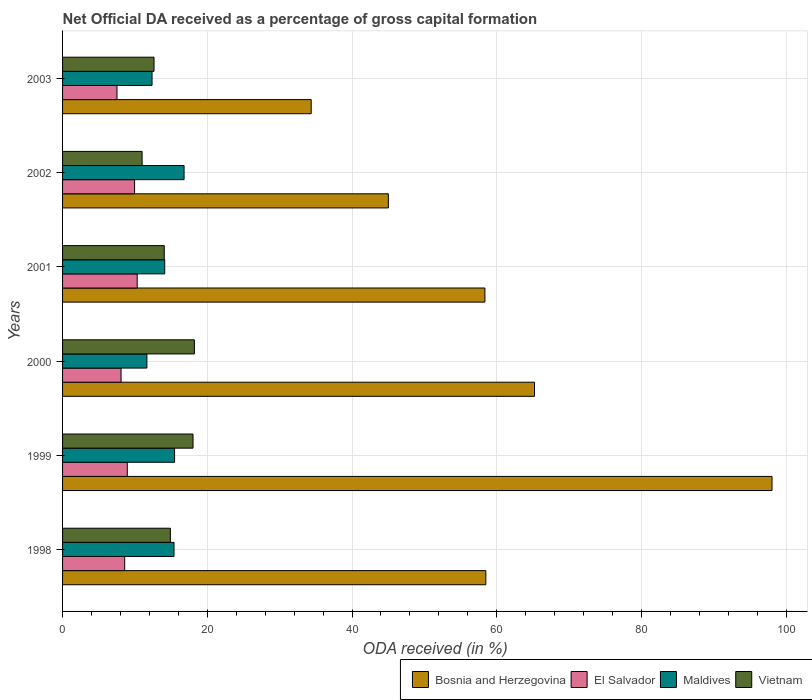How many different coloured bars are there?
Provide a succinct answer. 4. How many groups of bars are there?
Ensure brevity in your answer.  6. What is the net ODA received in Vietnam in 2002?
Provide a short and direct response. 10.99. Across all years, what is the maximum net ODA received in Maldives?
Your answer should be compact. 16.79. Across all years, what is the minimum net ODA received in El Salvador?
Make the answer very short. 7.52. In which year was the net ODA received in El Salvador maximum?
Offer a terse response. 2001. What is the total net ODA received in Bosnia and Herzegovina in the graph?
Your answer should be compact. 359.48. What is the difference between the net ODA received in Maldives in 1999 and that in 2001?
Offer a very short reply. 1.36. What is the difference between the net ODA received in Vietnam in 1999 and the net ODA received in El Salvador in 2003?
Offer a very short reply. 10.51. What is the average net ODA received in El Salvador per year?
Offer a terse response. 8.9. In the year 1999, what is the difference between the net ODA received in Bosnia and Herzegovina and net ODA received in El Salvador?
Provide a short and direct response. 89.09. What is the ratio of the net ODA received in Vietnam in 1999 to that in 2003?
Your answer should be compact. 1.43. Is the difference between the net ODA received in Bosnia and Herzegovina in 1999 and 2002 greater than the difference between the net ODA received in El Salvador in 1999 and 2002?
Provide a short and direct response. Yes. What is the difference between the highest and the second highest net ODA received in Bosnia and Herzegovina?
Offer a terse response. 32.82. What is the difference between the highest and the lowest net ODA received in El Salvador?
Keep it short and to the point. 2.79. In how many years, is the net ODA received in El Salvador greater than the average net ODA received in El Salvador taken over all years?
Your response must be concise. 3. Is the sum of the net ODA received in Vietnam in 2000 and 2003 greater than the maximum net ODA received in El Salvador across all years?
Make the answer very short. Yes. Is it the case that in every year, the sum of the net ODA received in Vietnam and net ODA received in Bosnia and Herzegovina is greater than the sum of net ODA received in El Salvador and net ODA received in Maldives?
Offer a terse response. Yes. What does the 1st bar from the top in 1999 represents?
Keep it short and to the point. Vietnam. What does the 3rd bar from the bottom in 1998 represents?
Make the answer very short. Maldives. Is it the case that in every year, the sum of the net ODA received in Maldives and net ODA received in Vietnam is greater than the net ODA received in El Salvador?
Your answer should be compact. Yes. How many bars are there?
Your answer should be compact. 24. Are all the bars in the graph horizontal?
Your answer should be very brief. Yes. What is the difference between two consecutive major ticks on the X-axis?
Your answer should be compact. 20. Does the graph contain any zero values?
Provide a succinct answer. No. Does the graph contain grids?
Your response must be concise. Yes. What is the title of the graph?
Your answer should be very brief. Net Official DA received as a percentage of gross capital formation. What is the label or title of the X-axis?
Offer a terse response. ODA received (in %). What is the label or title of the Y-axis?
Your answer should be compact. Years. What is the ODA received (in %) in Bosnia and Herzegovina in 1998?
Your answer should be very brief. 58.49. What is the ODA received (in %) in El Salvador in 1998?
Ensure brevity in your answer.  8.58. What is the ODA received (in %) of Maldives in 1998?
Keep it short and to the point. 15.4. What is the ODA received (in %) in Vietnam in 1998?
Provide a short and direct response. 14.89. What is the ODA received (in %) in Bosnia and Herzegovina in 1999?
Offer a terse response. 98.04. What is the ODA received (in %) of El Salvador in 1999?
Keep it short and to the point. 8.94. What is the ODA received (in %) of Maldives in 1999?
Your response must be concise. 15.48. What is the ODA received (in %) in Vietnam in 1999?
Give a very brief answer. 18.03. What is the ODA received (in %) in Bosnia and Herzegovina in 2000?
Ensure brevity in your answer.  65.21. What is the ODA received (in %) in El Salvador in 2000?
Give a very brief answer. 8.08. What is the ODA received (in %) in Maldives in 2000?
Provide a succinct answer. 11.65. What is the ODA received (in %) in Vietnam in 2000?
Offer a very short reply. 18.22. What is the ODA received (in %) in Bosnia and Herzegovina in 2001?
Your response must be concise. 58.36. What is the ODA received (in %) in El Salvador in 2001?
Provide a short and direct response. 10.31. What is the ODA received (in %) in Maldives in 2001?
Provide a short and direct response. 14.12. What is the ODA received (in %) in Vietnam in 2001?
Your response must be concise. 14.05. What is the ODA received (in %) in Bosnia and Herzegovina in 2002?
Your answer should be compact. 45.02. What is the ODA received (in %) of El Salvador in 2002?
Offer a terse response. 9.95. What is the ODA received (in %) in Maldives in 2002?
Your answer should be very brief. 16.79. What is the ODA received (in %) in Vietnam in 2002?
Give a very brief answer. 10.99. What is the ODA received (in %) of Bosnia and Herzegovina in 2003?
Keep it short and to the point. 34.36. What is the ODA received (in %) of El Salvador in 2003?
Your response must be concise. 7.52. What is the ODA received (in %) in Maldives in 2003?
Offer a terse response. 12.36. What is the ODA received (in %) of Vietnam in 2003?
Offer a terse response. 12.64. Across all years, what is the maximum ODA received (in %) in Bosnia and Herzegovina?
Offer a very short reply. 98.04. Across all years, what is the maximum ODA received (in %) in El Salvador?
Keep it short and to the point. 10.31. Across all years, what is the maximum ODA received (in %) of Maldives?
Provide a short and direct response. 16.79. Across all years, what is the maximum ODA received (in %) in Vietnam?
Ensure brevity in your answer.  18.22. Across all years, what is the minimum ODA received (in %) of Bosnia and Herzegovina?
Ensure brevity in your answer.  34.36. Across all years, what is the minimum ODA received (in %) in El Salvador?
Keep it short and to the point. 7.52. Across all years, what is the minimum ODA received (in %) in Maldives?
Make the answer very short. 11.65. Across all years, what is the minimum ODA received (in %) in Vietnam?
Offer a terse response. 10.99. What is the total ODA received (in %) in Bosnia and Herzegovina in the graph?
Give a very brief answer. 359.48. What is the total ODA received (in %) in El Salvador in the graph?
Offer a very short reply. 53.39. What is the total ODA received (in %) of Maldives in the graph?
Make the answer very short. 85.8. What is the total ODA received (in %) of Vietnam in the graph?
Ensure brevity in your answer.  88.82. What is the difference between the ODA received (in %) of Bosnia and Herzegovina in 1998 and that in 1999?
Give a very brief answer. -39.55. What is the difference between the ODA received (in %) in El Salvador in 1998 and that in 1999?
Your response must be concise. -0.36. What is the difference between the ODA received (in %) in Maldives in 1998 and that in 1999?
Ensure brevity in your answer.  -0.08. What is the difference between the ODA received (in %) of Vietnam in 1998 and that in 1999?
Your answer should be compact. -3.13. What is the difference between the ODA received (in %) in Bosnia and Herzegovina in 1998 and that in 2000?
Offer a terse response. -6.73. What is the difference between the ODA received (in %) in El Salvador in 1998 and that in 2000?
Provide a succinct answer. 0.5. What is the difference between the ODA received (in %) of Maldives in 1998 and that in 2000?
Your answer should be compact. 3.75. What is the difference between the ODA received (in %) in Vietnam in 1998 and that in 2000?
Your answer should be very brief. -3.32. What is the difference between the ODA received (in %) of Bosnia and Herzegovina in 1998 and that in 2001?
Provide a short and direct response. 0.13. What is the difference between the ODA received (in %) of El Salvador in 1998 and that in 2001?
Your answer should be compact. -1.73. What is the difference between the ODA received (in %) of Maldives in 1998 and that in 2001?
Your answer should be compact. 1.28. What is the difference between the ODA received (in %) of Vietnam in 1998 and that in 2001?
Provide a short and direct response. 0.84. What is the difference between the ODA received (in %) of Bosnia and Herzegovina in 1998 and that in 2002?
Make the answer very short. 13.47. What is the difference between the ODA received (in %) of El Salvador in 1998 and that in 2002?
Make the answer very short. -1.37. What is the difference between the ODA received (in %) of Maldives in 1998 and that in 2002?
Keep it short and to the point. -1.39. What is the difference between the ODA received (in %) in Vietnam in 1998 and that in 2002?
Your response must be concise. 3.9. What is the difference between the ODA received (in %) in Bosnia and Herzegovina in 1998 and that in 2003?
Your answer should be compact. 24.13. What is the difference between the ODA received (in %) in El Salvador in 1998 and that in 2003?
Offer a very short reply. 1.06. What is the difference between the ODA received (in %) in Maldives in 1998 and that in 2003?
Provide a short and direct response. 3.04. What is the difference between the ODA received (in %) in Vietnam in 1998 and that in 2003?
Make the answer very short. 2.26. What is the difference between the ODA received (in %) in Bosnia and Herzegovina in 1999 and that in 2000?
Offer a very short reply. 32.82. What is the difference between the ODA received (in %) of El Salvador in 1999 and that in 2000?
Keep it short and to the point. 0.86. What is the difference between the ODA received (in %) of Maldives in 1999 and that in 2000?
Provide a succinct answer. 3.83. What is the difference between the ODA received (in %) of Vietnam in 1999 and that in 2000?
Your response must be concise. -0.19. What is the difference between the ODA received (in %) of Bosnia and Herzegovina in 1999 and that in 2001?
Your answer should be compact. 39.68. What is the difference between the ODA received (in %) of El Salvador in 1999 and that in 2001?
Your answer should be compact. -1.37. What is the difference between the ODA received (in %) of Maldives in 1999 and that in 2001?
Provide a short and direct response. 1.36. What is the difference between the ODA received (in %) in Vietnam in 1999 and that in 2001?
Offer a very short reply. 3.97. What is the difference between the ODA received (in %) in Bosnia and Herzegovina in 1999 and that in 2002?
Make the answer very short. 53.01. What is the difference between the ODA received (in %) in El Salvador in 1999 and that in 2002?
Give a very brief answer. -1.01. What is the difference between the ODA received (in %) of Maldives in 1999 and that in 2002?
Provide a short and direct response. -1.31. What is the difference between the ODA received (in %) of Vietnam in 1999 and that in 2002?
Provide a short and direct response. 7.04. What is the difference between the ODA received (in %) in Bosnia and Herzegovina in 1999 and that in 2003?
Offer a terse response. 63.68. What is the difference between the ODA received (in %) of El Salvador in 1999 and that in 2003?
Your answer should be very brief. 1.42. What is the difference between the ODA received (in %) of Maldives in 1999 and that in 2003?
Keep it short and to the point. 3.11. What is the difference between the ODA received (in %) of Vietnam in 1999 and that in 2003?
Your answer should be compact. 5.39. What is the difference between the ODA received (in %) of Bosnia and Herzegovina in 2000 and that in 2001?
Your response must be concise. 6.85. What is the difference between the ODA received (in %) of El Salvador in 2000 and that in 2001?
Keep it short and to the point. -2.23. What is the difference between the ODA received (in %) in Maldives in 2000 and that in 2001?
Keep it short and to the point. -2.46. What is the difference between the ODA received (in %) of Vietnam in 2000 and that in 2001?
Offer a very short reply. 4.16. What is the difference between the ODA received (in %) in Bosnia and Herzegovina in 2000 and that in 2002?
Your answer should be compact. 20.19. What is the difference between the ODA received (in %) of El Salvador in 2000 and that in 2002?
Make the answer very short. -1.87. What is the difference between the ODA received (in %) of Maldives in 2000 and that in 2002?
Provide a short and direct response. -5.14. What is the difference between the ODA received (in %) of Vietnam in 2000 and that in 2002?
Your answer should be compact. 7.23. What is the difference between the ODA received (in %) in Bosnia and Herzegovina in 2000 and that in 2003?
Your answer should be very brief. 30.86. What is the difference between the ODA received (in %) of El Salvador in 2000 and that in 2003?
Your answer should be compact. 0.56. What is the difference between the ODA received (in %) of Maldives in 2000 and that in 2003?
Offer a very short reply. -0.71. What is the difference between the ODA received (in %) of Vietnam in 2000 and that in 2003?
Make the answer very short. 5.58. What is the difference between the ODA received (in %) of Bosnia and Herzegovina in 2001 and that in 2002?
Offer a terse response. 13.34. What is the difference between the ODA received (in %) of El Salvador in 2001 and that in 2002?
Provide a succinct answer. 0.36. What is the difference between the ODA received (in %) of Maldives in 2001 and that in 2002?
Your response must be concise. -2.67. What is the difference between the ODA received (in %) in Vietnam in 2001 and that in 2002?
Your answer should be very brief. 3.06. What is the difference between the ODA received (in %) of Bosnia and Herzegovina in 2001 and that in 2003?
Keep it short and to the point. 24. What is the difference between the ODA received (in %) of El Salvador in 2001 and that in 2003?
Your response must be concise. 2.79. What is the difference between the ODA received (in %) of Maldives in 2001 and that in 2003?
Provide a short and direct response. 1.75. What is the difference between the ODA received (in %) in Vietnam in 2001 and that in 2003?
Ensure brevity in your answer.  1.42. What is the difference between the ODA received (in %) in Bosnia and Herzegovina in 2002 and that in 2003?
Provide a short and direct response. 10.66. What is the difference between the ODA received (in %) in El Salvador in 2002 and that in 2003?
Ensure brevity in your answer.  2.43. What is the difference between the ODA received (in %) of Maldives in 2002 and that in 2003?
Make the answer very short. 4.43. What is the difference between the ODA received (in %) in Vietnam in 2002 and that in 2003?
Make the answer very short. -1.65. What is the difference between the ODA received (in %) of Bosnia and Herzegovina in 1998 and the ODA received (in %) of El Salvador in 1999?
Keep it short and to the point. 49.55. What is the difference between the ODA received (in %) of Bosnia and Herzegovina in 1998 and the ODA received (in %) of Maldives in 1999?
Offer a terse response. 43.01. What is the difference between the ODA received (in %) in Bosnia and Herzegovina in 1998 and the ODA received (in %) in Vietnam in 1999?
Your answer should be compact. 40.46. What is the difference between the ODA received (in %) of El Salvador in 1998 and the ODA received (in %) of Maldives in 1999?
Keep it short and to the point. -6.89. What is the difference between the ODA received (in %) in El Salvador in 1998 and the ODA received (in %) in Vietnam in 1999?
Provide a short and direct response. -9.44. What is the difference between the ODA received (in %) of Maldives in 1998 and the ODA received (in %) of Vietnam in 1999?
Provide a succinct answer. -2.62. What is the difference between the ODA received (in %) of Bosnia and Herzegovina in 1998 and the ODA received (in %) of El Salvador in 2000?
Provide a short and direct response. 50.41. What is the difference between the ODA received (in %) of Bosnia and Herzegovina in 1998 and the ODA received (in %) of Maldives in 2000?
Ensure brevity in your answer.  46.84. What is the difference between the ODA received (in %) of Bosnia and Herzegovina in 1998 and the ODA received (in %) of Vietnam in 2000?
Ensure brevity in your answer.  40.27. What is the difference between the ODA received (in %) of El Salvador in 1998 and the ODA received (in %) of Maldives in 2000?
Provide a succinct answer. -3.07. What is the difference between the ODA received (in %) of El Salvador in 1998 and the ODA received (in %) of Vietnam in 2000?
Your response must be concise. -9.63. What is the difference between the ODA received (in %) in Maldives in 1998 and the ODA received (in %) in Vietnam in 2000?
Give a very brief answer. -2.81. What is the difference between the ODA received (in %) in Bosnia and Herzegovina in 1998 and the ODA received (in %) in El Salvador in 2001?
Make the answer very short. 48.17. What is the difference between the ODA received (in %) in Bosnia and Herzegovina in 1998 and the ODA received (in %) in Maldives in 2001?
Your response must be concise. 44.37. What is the difference between the ODA received (in %) of Bosnia and Herzegovina in 1998 and the ODA received (in %) of Vietnam in 2001?
Offer a very short reply. 44.43. What is the difference between the ODA received (in %) of El Salvador in 1998 and the ODA received (in %) of Maldives in 2001?
Provide a short and direct response. -5.53. What is the difference between the ODA received (in %) in El Salvador in 1998 and the ODA received (in %) in Vietnam in 2001?
Offer a very short reply. -5.47. What is the difference between the ODA received (in %) in Maldives in 1998 and the ODA received (in %) in Vietnam in 2001?
Make the answer very short. 1.35. What is the difference between the ODA received (in %) in Bosnia and Herzegovina in 1998 and the ODA received (in %) in El Salvador in 2002?
Provide a succinct answer. 48.54. What is the difference between the ODA received (in %) of Bosnia and Herzegovina in 1998 and the ODA received (in %) of Maldives in 2002?
Provide a succinct answer. 41.7. What is the difference between the ODA received (in %) of Bosnia and Herzegovina in 1998 and the ODA received (in %) of Vietnam in 2002?
Your answer should be compact. 47.5. What is the difference between the ODA received (in %) in El Salvador in 1998 and the ODA received (in %) in Maldives in 2002?
Provide a succinct answer. -8.21. What is the difference between the ODA received (in %) of El Salvador in 1998 and the ODA received (in %) of Vietnam in 2002?
Your answer should be very brief. -2.41. What is the difference between the ODA received (in %) in Maldives in 1998 and the ODA received (in %) in Vietnam in 2002?
Offer a very short reply. 4.41. What is the difference between the ODA received (in %) of Bosnia and Herzegovina in 1998 and the ODA received (in %) of El Salvador in 2003?
Ensure brevity in your answer.  50.97. What is the difference between the ODA received (in %) in Bosnia and Herzegovina in 1998 and the ODA received (in %) in Maldives in 2003?
Ensure brevity in your answer.  46.12. What is the difference between the ODA received (in %) of Bosnia and Herzegovina in 1998 and the ODA received (in %) of Vietnam in 2003?
Offer a very short reply. 45.85. What is the difference between the ODA received (in %) of El Salvador in 1998 and the ODA received (in %) of Maldives in 2003?
Keep it short and to the point. -3.78. What is the difference between the ODA received (in %) of El Salvador in 1998 and the ODA received (in %) of Vietnam in 2003?
Ensure brevity in your answer.  -4.06. What is the difference between the ODA received (in %) in Maldives in 1998 and the ODA received (in %) in Vietnam in 2003?
Provide a short and direct response. 2.76. What is the difference between the ODA received (in %) of Bosnia and Herzegovina in 1999 and the ODA received (in %) of El Salvador in 2000?
Make the answer very short. 89.95. What is the difference between the ODA received (in %) in Bosnia and Herzegovina in 1999 and the ODA received (in %) in Maldives in 2000?
Offer a very short reply. 86.38. What is the difference between the ODA received (in %) of Bosnia and Herzegovina in 1999 and the ODA received (in %) of Vietnam in 2000?
Offer a terse response. 79.82. What is the difference between the ODA received (in %) in El Salvador in 1999 and the ODA received (in %) in Maldives in 2000?
Keep it short and to the point. -2.71. What is the difference between the ODA received (in %) in El Salvador in 1999 and the ODA received (in %) in Vietnam in 2000?
Ensure brevity in your answer.  -9.27. What is the difference between the ODA received (in %) in Maldives in 1999 and the ODA received (in %) in Vietnam in 2000?
Offer a terse response. -2.74. What is the difference between the ODA received (in %) of Bosnia and Herzegovina in 1999 and the ODA received (in %) of El Salvador in 2001?
Your answer should be compact. 87.72. What is the difference between the ODA received (in %) of Bosnia and Herzegovina in 1999 and the ODA received (in %) of Maldives in 2001?
Your response must be concise. 83.92. What is the difference between the ODA received (in %) in Bosnia and Herzegovina in 1999 and the ODA received (in %) in Vietnam in 2001?
Your response must be concise. 83.98. What is the difference between the ODA received (in %) in El Salvador in 1999 and the ODA received (in %) in Maldives in 2001?
Your answer should be compact. -5.17. What is the difference between the ODA received (in %) of El Salvador in 1999 and the ODA received (in %) of Vietnam in 2001?
Your answer should be very brief. -5.11. What is the difference between the ODA received (in %) of Maldives in 1999 and the ODA received (in %) of Vietnam in 2001?
Give a very brief answer. 1.42. What is the difference between the ODA received (in %) of Bosnia and Herzegovina in 1999 and the ODA received (in %) of El Salvador in 2002?
Provide a succinct answer. 88.09. What is the difference between the ODA received (in %) in Bosnia and Herzegovina in 1999 and the ODA received (in %) in Maldives in 2002?
Give a very brief answer. 81.25. What is the difference between the ODA received (in %) of Bosnia and Herzegovina in 1999 and the ODA received (in %) of Vietnam in 2002?
Offer a very short reply. 87.05. What is the difference between the ODA received (in %) of El Salvador in 1999 and the ODA received (in %) of Maldives in 2002?
Provide a short and direct response. -7.85. What is the difference between the ODA received (in %) of El Salvador in 1999 and the ODA received (in %) of Vietnam in 2002?
Offer a very short reply. -2.05. What is the difference between the ODA received (in %) in Maldives in 1999 and the ODA received (in %) in Vietnam in 2002?
Provide a short and direct response. 4.49. What is the difference between the ODA received (in %) of Bosnia and Herzegovina in 1999 and the ODA received (in %) of El Salvador in 2003?
Give a very brief answer. 90.52. What is the difference between the ODA received (in %) in Bosnia and Herzegovina in 1999 and the ODA received (in %) in Maldives in 2003?
Make the answer very short. 85.67. What is the difference between the ODA received (in %) in Bosnia and Herzegovina in 1999 and the ODA received (in %) in Vietnam in 2003?
Give a very brief answer. 85.4. What is the difference between the ODA received (in %) of El Salvador in 1999 and the ODA received (in %) of Maldives in 2003?
Provide a short and direct response. -3.42. What is the difference between the ODA received (in %) of El Salvador in 1999 and the ODA received (in %) of Vietnam in 2003?
Give a very brief answer. -3.7. What is the difference between the ODA received (in %) in Maldives in 1999 and the ODA received (in %) in Vietnam in 2003?
Offer a very short reply. 2.84. What is the difference between the ODA received (in %) in Bosnia and Herzegovina in 2000 and the ODA received (in %) in El Salvador in 2001?
Provide a short and direct response. 54.9. What is the difference between the ODA received (in %) of Bosnia and Herzegovina in 2000 and the ODA received (in %) of Maldives in 2001?
Your answer should be compact. 51.1. What is the difference between the ODA received (in %) in Bosnia and Herzegovina in 2000 and the ODA received (in %) in Vietnam in 2001?
Give a very brief answer. 51.16. What is the difference between the ODA received (in %) of El Salvador in 2000 and the ODA received (in %) of Maldives in 2001?
Offer a very short reply. -6.04. What is the difference between the ODA received (in %) in El Salvador in 2000 and the ODA received (in %) in Vietnam in 2001?
Ensure brevity in your answer.  -5.97. What is the difference between the ODA received (in %) in Maldives in 2000 and the ODA received (in %) in Vietnam in 2001?
Give a very brief answer. -2.4. What is the difference between the ODA received (in %) of Bosnia and Herzegovina in 2000 and the ODA received (in %) of El Salvador in 2002?
Your answer should be very brief. 55.26. What is the difference between the ODA received (in %) in Bosnia and Herzegovina in 2000 and the ODA received (in %) in Maldives in 2002?
Your answer should be compact. 48.42. What is the difference between the ODA received (in %) in Bosnia and Herzegovina in 2000 and the ODA received (in %) in Vietnam in 2002?
Provide a short and direct response. 54.22. What is the difference between the ODA received (in %) of El Salvador in 2000 and the ODA received (in %) of Maldives in 2002?
Provide a succinct answer. -8.71. What is the difference between the ODA received (in %) in El Salvador in 2000 and the ODA received (in %) in Vietnam in 2002?
Provide a short and direct response. -2.91. What is the difference between the ODA received (in %) of Maldives in 2000 and the ODA received (in %) of Vietnam in 2002?
Give a very brief answer. 0.66. What is the difference between the ODA received (in %) of Bosnia and Herzegovina in 2000 and the ODA received (in %) of El Salvador in 2003?
Your response must be concise. 57.69. What is the difference between the ODA received (in %) in Bosnia and Herzegovina in 2000 and the ODA received (in %) in Maldives in 2003?
Ensure brevity in your answer.  52.85. What is the difference between the ODA received (in %) in Bosnia and Herzegovina in 2000 and the ODA received (in %) in Vietnam in 2003?
Offer a terse response. 52.58. What is the difference between the ODA received (in %) in El Salvador in 2000 and the ODA received (in %) in Maldives in 2003?
Provide a short and direct response. -4.28. What is the difference between the ODA received (in %) of El Salvador in 2000 and the ODA received (in %) of Vietnam in 2003?
Give a very brief answer. -4.56. What is the difference between the ODA received (in %) of Maldives in 2000 and the ODA received (in %) of Vietnam in 2003?
Your response must be concise. -0.99. What is the difference between the ODA received (in %) of Bosnia and Herzegovina in 2001 and the ODA received (in %) of El Salvador in 2002?
Offer a terse response. 48.41. What is the difference between the ODA received (in %) of Bosnia and Herzegovina in 2001 and the ODA received (in %) of Maldives in 2002?
Give a very brief answer. 41.57. What is the difference between the ODA received (in %) in Bosnia and Herzegovina in 2001 and the ODA received (in %) in Vietnam in 2002?
Your answer should be compact. 47.37. What is the difference between the ODA received (in %) in El Salvador in 2001 and the ODA received (in %) in Maldives in 2002?
Keep it short and to the point. -6.48. What is the difference between the ODA received (in %) in El Salvador in 2001 and the ODA received (in %) in Vietnam in 2002?
Your answer should be compact. -0.68. What is the difference between the ODA received (in %) in Maldives in 2001 and the ODA received (in %) in Vietnam in 2002?
Provide a succinct answer. 3.13. What is the difference between the ODA received (in %) of Bosnia and Herzegovina in 2001 and the ODA received (in %) of El Salvador in 2003?
Provide a succinct answer. 50.84. What is the difference between the ODA received (in %) of Bosnia and Herzegovina in 2001 and the ODA received (in %) of Maldives in 2003?
Offer a terse response. 46. What is the difference between the ODA received (in %) of Bosnia and Herzegovina in 2001 and the ODA received (in %) of Vietnam in 2003?
Offer a terse response. 45.72. What is the difference between the ODA received (in %) in El Salvador in 2001 and the ODA received (in %) in Maldives in 2003?
Provide a succinct answer. -2.05. What is the difference between the ODA received (in %) of El Salvador in 2001 and the ODA received (in %) of Vietnam in 2003?
Keep it short and to the point. -2.32. What is the difference between the ODA received (in %) of Maldives in 2001 and the ODA received (in %) of Vietnam in 2003?
Your answer should be compact. 1.48. What is the difference between the ODA received (in %) in Bosnia and Herzegovina in 2002 and the ODA received (in %) in El Salvador in 2003?
Keep it short and to the point. 37.5. What is the difference between the ODA received (in %) in Bosnia and Herzegovina in 2002 and the ODA received (in %) in Maldives in 2003?
Your response must be concise. 32.66. What is the difference between the ODA received (in %) of Bosnia and Herzegovina in 2002 and the ODA received (in %) of Vietnam in 2003?
Make the answer very short. 32.38. What is the difference between the ODA received (in %) in El Salvador in 2002 and the ODA received (in %) in Maldives in 2003?
Provide a succinct answer. -2.41. What is the difference between the ODA received (in %) of El Salvador in 2002 and the ODA received (in %) of Vietnam in 2003?
Ensure brevity in your answer.  -2.69. What is the difference between the ODA received (in %) in Maldives in 2002 and the ODA received (in %) in Vietnam in 2003?
Ensure brevity in your answer.  4.15. What is the average ODA received (in %) of Bosnia and Herzegovina per year?
Give a very brief answer. 59.91. What is the average ODA received (in %) of El Salvador per year?
Keep it short and to the point. 8.9. What is the average ODA received (in %) of Maldives per year?
Make the answer very short. 14.3. What is the average ODA received (in %) of Vietnam per year?
Give a very brief answer. 14.8. In the year 1998, what is the difference between the ODA received (in %) in Bosnia and Herzegovina and ODA received (in %) in El Salvador?
Provide a short and direct response. 49.91. In the year 1998, what is the difference between the ODA received (in %) in Bosnia and Herzegovina and ODA received (in %) in Maldives?
Your answer should be compact. 43.09. In the year 1998, what is the difference between the ODA received (in %) in Bosnia and Herzegovina and ODA received (in %) in Vietnam?
Make the answer very short. 43.59. In the year 1998, what is the difference between the ODA received (in %) of El Salvador and ODA received (in %) of Maldives?
Your response must be concise. -6.82. In the year 1998, what is the difference between the ODA received (in %) of El Salvador and ODA received (in %) of Vietnam?
Your response must be concise. -6.31. In the year 1998, what is the difference between the ODA received (in %) in Maldives and ODA received (in %) in Vietnam?
Your response must be concise. 0.51. In the year 1999, what is the difference between the ODA received (in %) of Bosnia and Herzegovina and ODA received (in %) of El Salvador?
Provide a short and direct response. 89.09. In the year 1999, what is the difference between the ODA received (in %) in Bosnia and Herzegovina and ODA received (in %) in Maldives?
Provide a succinct answer. 82.56. In the year 1999, what is the difference between the ODA received (in %) in Bosnia and Herzegovina and ODA received (in %) in Vietnam?
Provide a succinct answer. 80.01. In the year 1999, what is the difference between the ODA received (in %) in El Salvador and ODA received (in %) in Maldives?
Give a very brief answer. -6.54. In the year 1999, what is the difference between the ODA received (in %) of El Salvador and ODA received (in %) of Vietnam?
Your response must be concise. -9.08. In the year 1999, what is the difference between the ODA received (in %) in Maldives and ODA received (in %) in Vietnam?
Offer a terse response. -2.55. In the year 2000, what is the difference between the ODA received (in %) in Bosnia and Herzegovina and ODA received (in %) in El Salvador?
Offer a very short reply. 57.13. In the year 2000, what is the difference between the ODA received (in %) of Bosnia and Herzegovina and ODA received (in %) of Maldives?
Provide a short and direct response. 53.56. In the year 2000, what is the difference between the ODA received (in %) of Bosnia and Herzegovina and ODA received (in %) of Vietnam?
Provide a short and direct response. 47. In the year 2000, what is the difference between the ODA received (in %) in El Salvador and ODA received (in %) in Maldives?
Keep it short and to the point. -3.57. In the year 2000, what is the difference between the ODA received (in %) of El Salvador and ODA received (in %) of Vietnam?
Your answer should be compact. -10.13. In the year 2000, what is the difference between the ODA received (in %) in Maldives and ODA received (in %) in Vietnam?
Your answer should be compact. -6.56. In the year 2001, what is the difference between the ODA received (in %) in Bosnia and Herzegovina and ODA received (in %) in El Salvador?
Provide a succinct answer. 48.05. In the year 2001, what is the difference between the ODA received (in %) in Bosnia and Herzegovina and ODA received (in %) in Maldives?
Offer a terse response. 44.24. In the year 2001, what is the difference between the ODA received (in %) of Bosnia and Herzegovina and ODA received (in %) of Vietnam?
Provide a short and direct response. 44.31. In the year 2001, what is the difference between the ODA received (in %) in El Salvador and ODA received (in %) in Maldives?
Give a very brief answer. -3.8. In the year 2001, what is the difference between the ODA received (in %) in El Salvador and ODA received (in %) in Vietnam?
Your answer should be very brief. -3.74. In the year 2001, what is the difference between the ODA received (in %) of Maldives and ODA received (in %) of Vietnam?
Make the answer very short. 0.06. In the year 2002, what is the difference between the ODA received (in %) in Bosnia and Herzegovina and ODA received (in %) in El Salvador?
Provide a short and direct response. 35.07. In the year 2002, what is the difference between the ODA received (in %) of Bosnia and Herzegovina and ODA received (in %) of Maldives?
Your response must be concise. 28.23. In the year 2002, what is the difference between the ODA received (in %) of Bosnia and Herzegovina and ODA received (in %) of Vietnam?
Your answer should be very brief. 34.03. In the year 2002, what is the difference between the ODA received (in %) in El Salvador and ODA received (in %) in Maldives?
Keep it short and to the point. -6.84. In the year 2002, what is the difference between the ODA received (in %) of El Salvador and ODA received (in %) of Vietnam?
Make the answer very short. -1.04. In the year 2002, what is the difference between the ODA received (in %) of Maldives and ODA received (in %) of Vietnam?
Offer a very short reply. 5.8. In the year 2003, what is the difference between the ODA received (in %) in Bosnia and Herzegovina and ODA received (in %) in El Salvador?
Make the answer very short. 26.84. In the year 2003, what is the difference between the ODA received (in %) in Bosnia and Herzegovina and ODA received (in %) in Maldives?
Your answer should be compact. 21.99. In the year 2003, what is the difference between the ODA received (in %) in Bosnia and Herzegovina and ODA received (in %) in Vietnam?
Give a very brief answer. 21.72. In the year 2003, what is the difference between the ODA received (in %) of El Salvador and ODA received (in %) of Maldives?
Ensure brevity in your answer.  -4.84. In the year 2003, what is the difference between the ODA received (in %) of El Salvador and ODA received (in %) of Vietnam?
Provide a short and direct response. -5.12. In the year 2003, what is the difference between the ODA received (in %) in Maldives and ODA received (in %) in Vietnam?
Ensure brevity in your answer.  -0.27. What is the ratio of the ODA received (in %) of Bosnia and Herzegovina in 1998 to that in 1999?
Offer a terse response. 0.6. What is the ratio of the ODA received (in %) of El Salvador in 1998 to that in 1999?
Provide a succinct answer. 0.96. What is the ratio of the ODA received (in %) in Maldives in 1998 to that in 1999?
Your response must be concise. 1. What is the ratio of the ODA received (in %) in Vietnam in 1998 to that in 1999?
Ensure brevity in your answer.  0.83. What is the ratio of the ODA received (in %) in Bosnia and Herzegovina in 1998 to that in 2000?
Provide a succinct answer. 0.9. What is the ratio of the ODA received (in %) of El Salvador in 1998 to that in 2000?
Your response must be concise. 1.06. What is the ratio of the ODA received (in %) of Maldives in 1998 to that in 2000?
Offer a very short reply. 1.32. What is the ratio of the ODA received (in %) in Vietnam in 1998 to that in 2000?
Provide a succinct answer. 0.82. What is the ratio of the ODA received (in %) of El Salvador in 1998 to that in 2001?
Offer a very short reply. 0.83. What is the ratio of the ODA received (in %) of Maldives in 1998 to that in 2001?
Ensure brevity in your answer.  1.09. What is the ratio of the ODA received (in %) in Vietnam in 1998 to that in 2001?
Provide a short and direct response. 1.06. What is the ratio of the ODA received (in %) in Bosnia and Herzegovina in 1998 to that in 2002?
Provide a short and direct response. 1.3. What is the ratio of the ODA received (in %) of El Salvador in 1998 to that in 2002?
Provide a short and direct response. 0.86. What is the ratio of the ODA received (in %) of Maldives in 1998 to that in 2002?
Provide a short and direct response. 0.92. What is the ratio of the ODA received (in %) in Vietnam in 1998 to that in 2002?
Give a very brief answer. 1.36. What is the ratio of the ODA received (in %) of Bosnia and Herzegovina in 1998 to that in 2003?
Provide a short and direct response. 1.7. What is the ratio of the ODA received (in %) in El Salvador in 1998 to that in 2003?
Keep it short and to the point. 1.14. What is the ratio of the ODA received (in %) of Maldives in 1998 to that in 2003?
Ensure brevity in your answer.  1.25. What is the ratio of the ODA received (in %) in Vietnam in 1998 to that in 2003?
Offer a very short reply. 1.18. What is the ratio of the ODA received (in %) in Bosnia and Herzegovina in 1999 to that in 2000?
Give a very brief answer. 1.5. What is the ratio of the ODA received (in %) in El Salvador in 1999 to that in 2000?
Your answer should be very brief. 1.11. What is the ratio of the ODA received (in %) in Maldives in 1999 to that in 2000?
Your answer should be compact. 1.33. What is the ratio of the ODA received (in %) of Vietnam in 1999 to that in 2000?
Offer a terse response. 0.99. What is the ratio of the ODA received (in %) of Bosnia and Herzegovina in 1999 to that in 2001?
Offer a terse response. 1.68. What is the ratio of the ODA received (in %) in El Salvador in 1999 to that in 2001?
Provide a succinct answer. 0.87. What is the ratio of the ODA received (in %) in Maldives in 1999 to that in 2001?
Your response must be concise. 1.1. What is the ratio of the ODA received (in %) of Vietnam in 1999 to that in 2001?
Make the answer very short. 1.28. What is the ratio of the ODA received (in %) in Bosnia and Herzegovina in 1999 to that in 2002?
Your answer should be very brief. 2.18. What is the ratio of the ODA received (in %) in El Salvador in 1999 to that in 2002?
Offer a terse response. 0.9. What is the ratio of the ODA received (in %) of Maldives in 1999 to that in 2002?
Make the answer very short. 0.92. What is the ratio of the ODA received (in %) of Vietnam in 1999 to that in 2002?
Keep it short and to the point. 1.64. What is the ratio of the ODA received (in %) in Bosnia and Herzegovina in 1999 to that in 2003?
Keep it short and to the point. 2.85. What is the ratio of the ODA received (in %) in El Salvador in 1999 to that in 2003?
Provide a succinct answer. 1.19. What is the ratio of the ODA received (in %) in Maldives in 1999 to that in 2003?
Offer a terse response. 1.25. What is the ratio of the ODA received (in %) of Vietnam in 1999 to that in 2003?
Provide a short and direct response. 1.43. What is the ratio of the ODA received (in %) of Bosnia and Herzegovina in 2000 to that in 2001?
Your response must be concise. 1.12. What is the ratio of the ODA received (in %) in El Salvador in 2000 to that in 2001?
Provide a succinct answer. 0.78. What is the ratio of the ODA received (in %) in Maldives in 2000 to that in 2001?
Your answer should be very brief. 0.83. What is the ratio of the ODA received (in %) of Vietnam in 2000 to that in 2001?
Your answer should be compact. 1.3. What is the ratio of the ODA received (in %) in Bosnia and Herzegovina in 2000 to that in 2002?
Provide a succinct answer. 1.45. What is the ratio of the ODA received (in %) in El Salvador in 2000 to that in 2002?
Your response must be concise. 0.81. What is the ratio of the ODA received (in %) in Maldives in 2000 to that in 2002?
Offer a very short reply. 0.69. What is the ratio of the ODA received (in %) in Vietnam in 2000 to that in 2002?
Ensure brevity in your answer.  1.66. What is the ratio of the ODA received (in %) of Bosnia and Herzegovina in 2000 to that in 2003?
Make the answer very short. 1.9. What is the ratio of the ODA received (in %) of El Salvador in 2000 to that in 2003?
Provide a short and direct response. 1.07. What is the ratio of the ODA received (in %) in Maldives in 2000 to that in 2003?
Your answer should be very brief. 0.94. What is the ratio of the ODA received (in %) of Vietnam in 2000 to that in 2003?
Your answer should be compact. 1.44. What is the ratio of the ODA received (in %) in Bosnia and Herzegovina in 2001 to that in 2002?
Give a very brief answer. 1.3. What is the ratio of the ODA received (in %) in El Salvador in 2001 to that in 2002?
Give a very brief answer. 1.04. What is the ratio of the ODA received (in %) in Maldives in 2001 to that in 2002?
Offer a terse response. 0.84. What is the ratio of the ODA received (in %) of Vietnam in 2001 to that in 2002?
Your response must be concise. 1.28. What is the ratio of the ODA received (in %) in Bosnia and Herzegovina in 2001 to that in 2003?
Make the answer very short. 1.7. What is the ratio of the ODA received (in %) in El Salvador in 2001 to that in 2003?
Provide a short and direct response. 1.37. What is the ratio of the ODA received (in %) of Maldives in 2001 to that in 2003?
Your response must be concise. 1.14. What is the ratio of the ODA received (in %) of Vietnam in 2001 to that in 2003?
Your answer should be compact. 1.11. What is the ratio of the ODA received (in %) of Bosnia and Herzegovina in 2002 to that in 2003?
Ensure brevity in your answer.  1.31. What is the ratio of the ODA received (in %) in El Salvador in 2002 to that in 2003?
Offer a terse response. 1.32. What is the ratio of the ODA received (in %) in Maldives in 2002 to that in 2003?
Give a very brief answer. 1.36. What is the ratio of the ODA received (in %) in Vietnam in 2002 to that in 2003?
Provide a succinct answer. 0.87. What is the difference between the highest and the second highest ODA received (in %) of Bosnia and Herzegovina?
Offer a very short reply. 32.82. What is the difference between the highest and the second highest ODA received (in %) of El Salvador?
Offer a very short reply. 0.36. What is the difference between the highest and the second highest ODA received (in %) of Maldives?
Give a very brief answer. 1.31. What is the difference between the highest and the second highest ODA received (in %) in Vietnam?
Ensure brevity in your answer.  0.19. What is the difference between the highest and the lowest ODA received (in %) of Bosnia and Herzegovina?
Offer a terse response. 63.68. What is the difference between the highest and the lowest ODA received (in %) of El Salvador?
Your response must be concise. 2.79. What is the difference between the highest and the lowest ODA received (in %) of Maldives?
Your response must be concise. 5.14. What is the difference between the highest and the lowest ODA received (in %) in Vietnam?
Make the answer very short. 7.23. 